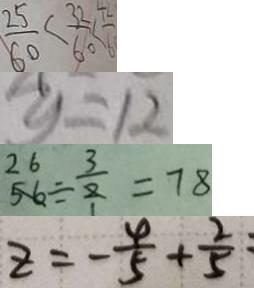Convert formula to latex. <formula><loc_0><loc_0><loc_500><loc_500>\frac { 2 5 } { 6 0 } < \frac { 3 2 } { 6 0 } < \frac { 7 } { 6 } 
 y = 1 2 
 5 6 \div \frac { 3 } { 2 } = 7 8 
 z = - \frac { 4 } { 5 } + \frac { 2 } { 5 }</formula> 